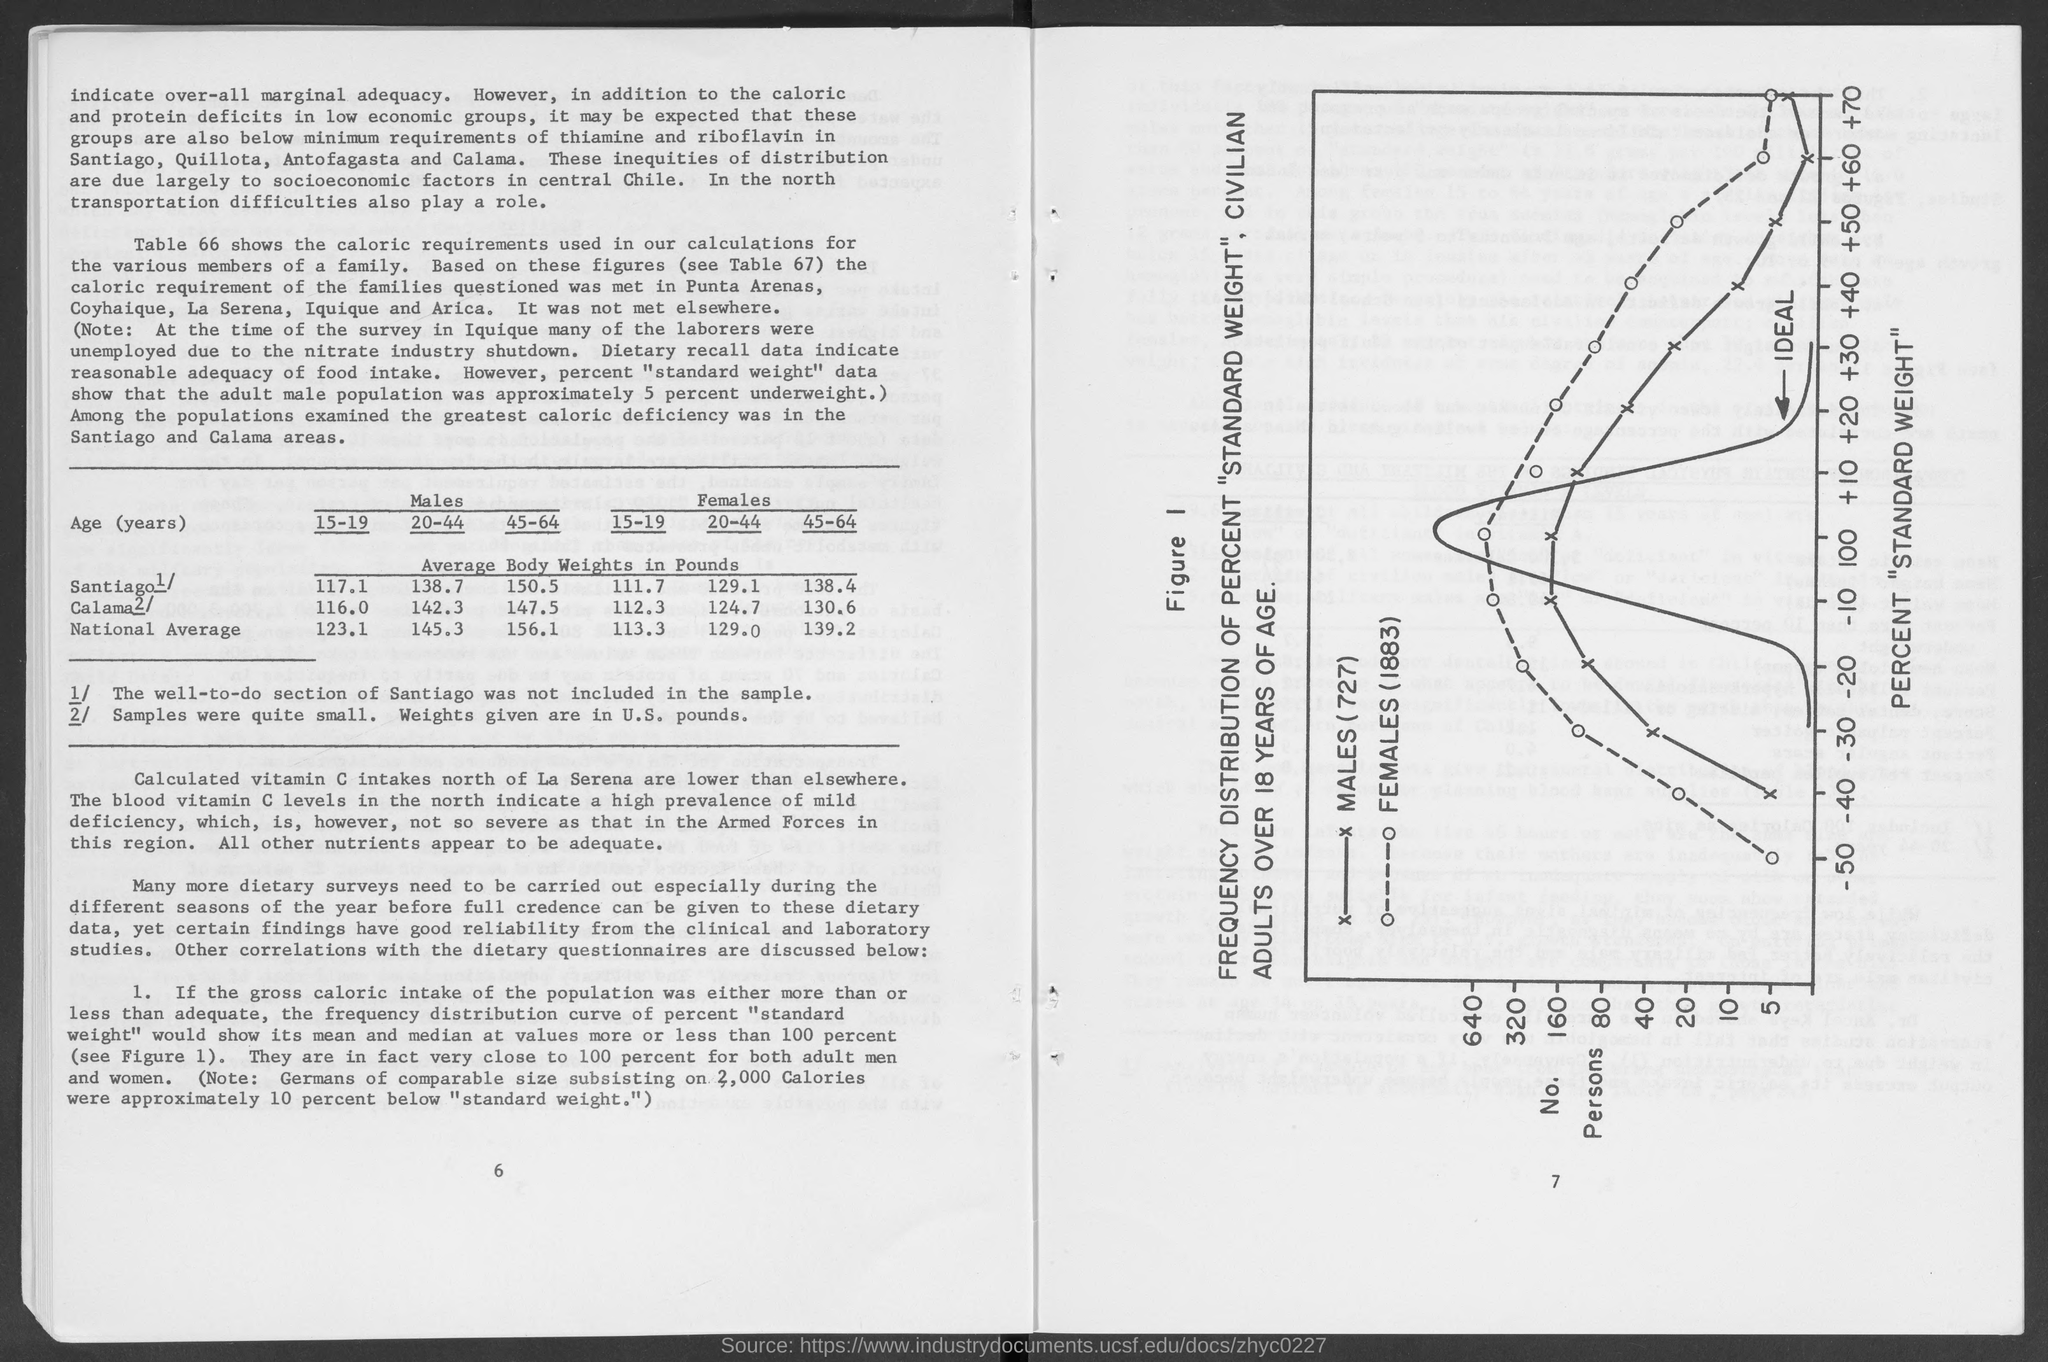What is the national average body weight in Females of the age group 45-64 ?
Give a very brief answer. 139.2. The population in  which areas were examined for greatest caloric deficiency ?
Your answer should be very brief. Santiago and Calama areas. What is the unit of weights given in the table ?
Offer a very short reply. U.S. Pounds. 